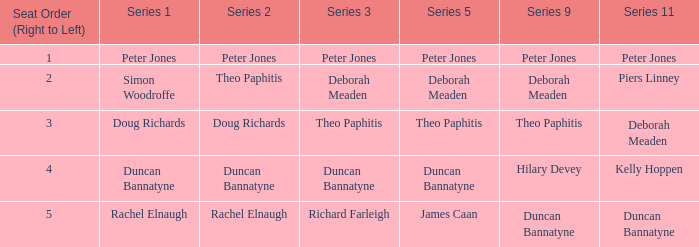Which Series 2 has a Series 3 of deborah meaden? Theo Paphitis. 